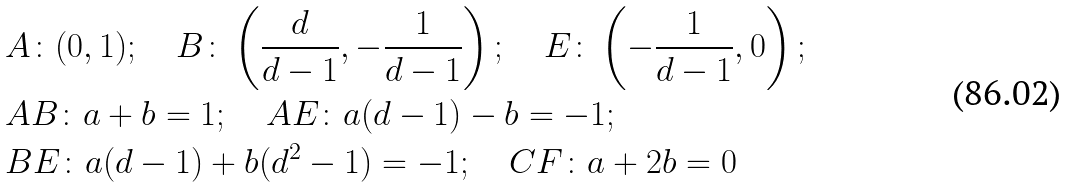Convert formula to latex. <formula><loc_0><loc_0><loc_500><loc_500>& A \colon ( 0 , 1 ) ; \quad B \colon \left ( \frac { d } { d - 1 } , - \frac { 1 } { d - 1 } \right ) ; \quad E \colon \left ( - \frac { 1 } { d - 1 } , 0 \right ) ; \\ & A B \colon a + b = 1 ; \quad A E \colon a ( d - 1 ) - b = - 1 ; \\ & B E \colon a ( d - 1 ) + b ( d ^ { 2 } - 1 ) = - 1 ; \quad C F \colon a + 2 b = 0</formula> 